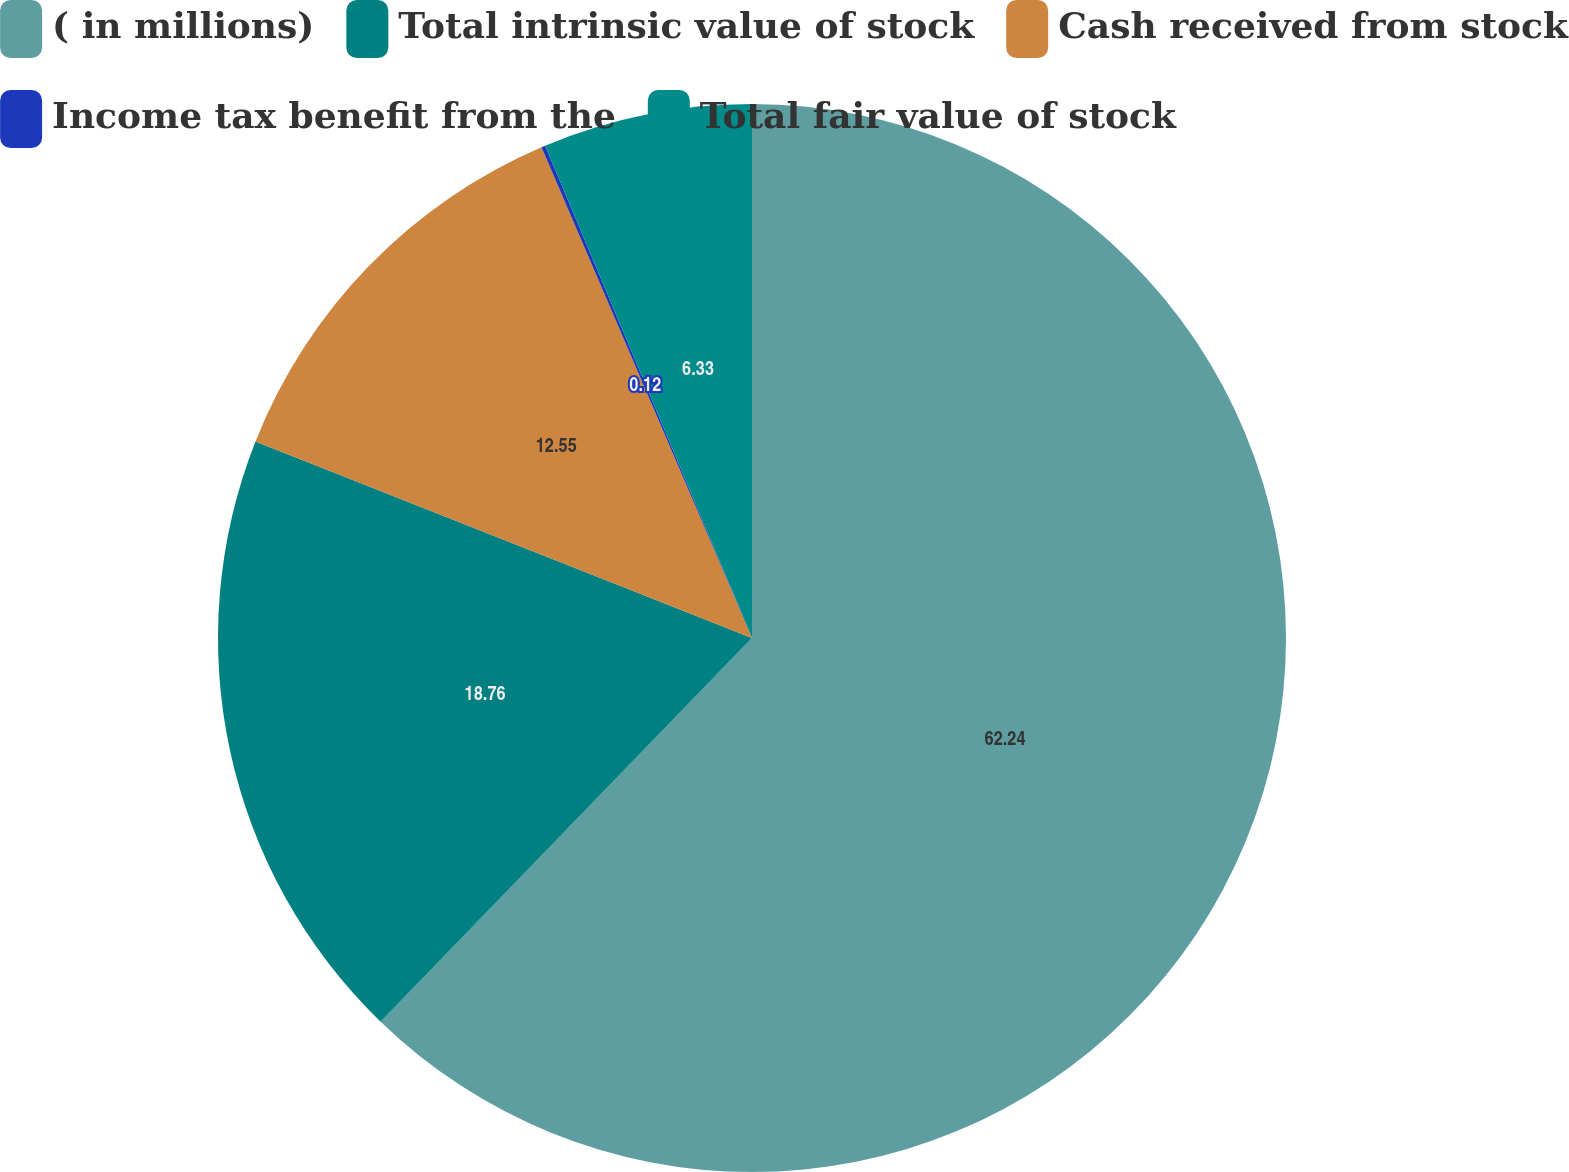Convert chart. <chart><loc_0><loc_0><loc_500><loc_500><pie_chart><fcel>( in millions)<fcel>Total intrinsic value of stock<fcel>Cash received from stock<fcel>Income tax benefit from the<fcel>Total fair value of stock<nl><fcel>62.24%<fcel>18.76%<fcel>12.55%<fcel>0.12%<fcel>6.33%<nl></chart> 